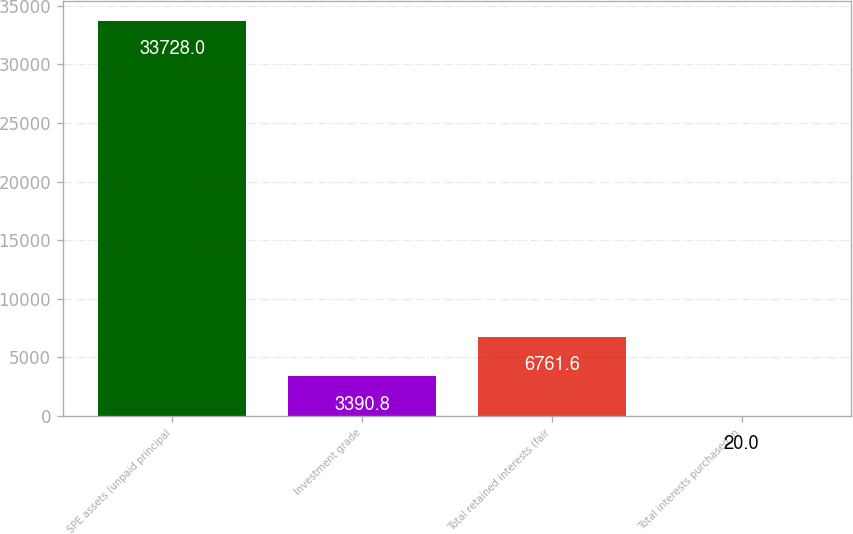Convert chart to OTSL. <chart><loc_0><loc_0><loc_500><loc_500><bar_chart><fcel>SPE assets (unpaid principal<fcel>Investment grade<fcel>Total retained interests (fair<fcel>Total interests purchased in<nl><fcel>33728<fcel>3390.8<fcel>6761.6<fcel>20<nl></chart> 